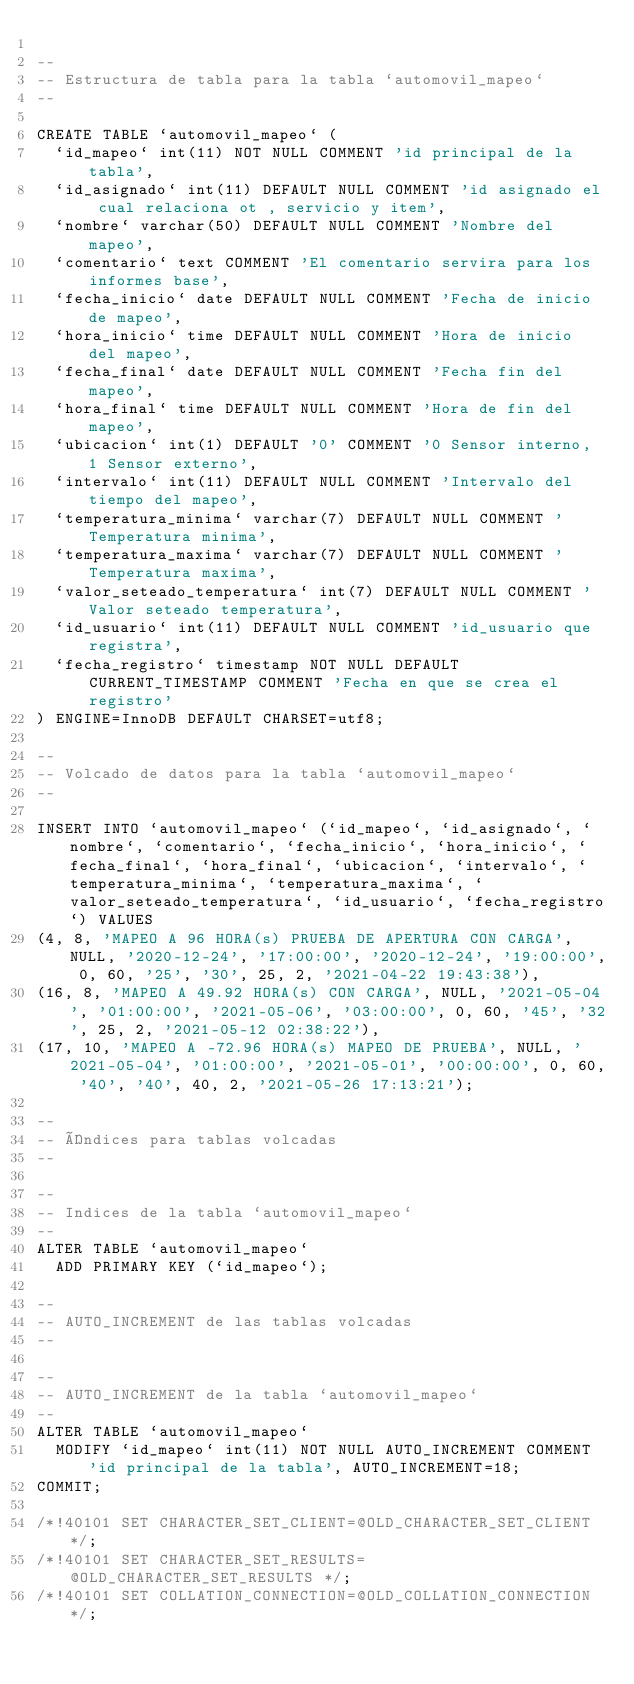<code> <loc_0><loc_0><loc_500><loc_500><_SQL_>
--
-- Estructura de tabla para la tabla `automovil_mapeo`
--

CREATE TABLE `automovil_mapeo` (
  `id_mapeo` int(11) NOT NULL COMMENT 'id principal de la tabla',
  `id_asignado` int(11) DEFAULT NULL COMMENT 'id asignado el cual relaciona ot , servicio y item',
  `nombre` varchar(50) DEFAULT NULL COMMENT 'Nombre del mapeo',
  `comentario` text COMMENT 'El comentario servira para los informes base',
  `fecha_inicio` date DEFAULT NULL COMMENT 'Fecha de inicio de mapeo',
  `hora_inicio` time DEFAULT NULL COMMENT 'Hora de inicio del mapeo',
  `fecha_final` date DEFAULT NULL COMMENT 'Fecha fin del mapeo',
  `hora_final` time DEFAULT NULL COMMENT 'Hora de fin del mapeo',
  `ubicacion` int(1) DEFAULT '0' COMMENT '0 Sensor interno, 1 Sensor externo',
  `intervalo` int(11) DEFAULT NULL COMMENT 'Intervalo del tiempo del mapeo',
  `temperatura_minima` varchar(7) DEFAULT NULL COMMENT 'Temperatura minima',
  `temperatura_maxima` varchar(7) DEFAULT NULL COMMENT 'Temperatura maxima',
  `valor_seteado_temperatura` int(7) DEFAULT NULL COMMENT 'Valor seteado temperatura',
  `id_usuario` int(11) DEFAULT NULL COMMENT 'id_usuario que registra',
  `fecha_registro` timestamp NOT NULL DEFAULT CURRENT_TIMESTAMP COMMENT 'Fecha en que se crea el registro'
) ENGINE=InnoDB DEFAULT CHARSET=utf8;

--
-- Volcado de datos para la tabla `automovil_mapeo`
--

INSERT INTO `automovil_mapeo` (`id_mapeo`, `id_asignado`, `nombre`, `comentario`, `fecha_inicio`, `hora_inicio`, `fecha_final`, `hora_final`, `ubicacion`, `intervalo`, `temperatura_minima`, `temperatura_maxima`, `valor_seteado_temperatura`, `id_usuario`, `fecha_registro`) VALUES
(4, 8, 'MAPEO A 96 HORA(s) PRUEBA DE APERTURA CON CARGA', NULL, '2020-12-24', '17:00:00', '2020-12-24', '19:00:00', 0, 60, '25', '30', 25, 2, '2021-04-22 19:43:38'),
(16, 8, 'MAPEO A 49.92 HORA(s) CON CARGA', NULL, '2021-05-04', '01:00:00', '2021-05-06', '03:00:00', 0, 60, '45', '32', 25, 2, '2021-05-12 02:38:22'),
(17, 10, 'MAPEO A -72.96 HORA(s) MAPEO DE PRUEBA', NULL, '2021-05-04', '01:00:00', '2021-05-01', '00:00:00', 0, 60, '40', '40', 40, 2, '2021-05-26 17:13:21');

--
-- Índices para tablas volcadas
--

--
-- Indices de la tabla `automovil_mapeo`
--
ALTER TABLE `automovil_mapeo`
  ADD PRIMARY KEY (`id_mapeo`);

--
-- AUTO_INCREMENT de las tablas volcadas
--

--
-- AUTO_INCREMENT de la tabla `automovil_mapeo`
--
ALTER TABLE `automovil_mapeo`
  MODIFY `id_mapeo` int(11) NOT NULL AUTO_INCREMENT COMMENT 'id principal de la tabla', AUTO_INCREMENT=18;
COMMIT;

/*!40101 SET CHARACTER_SET_CLIENT=@OLD_CHARACTER_SET_CLIENT */;
/*!40101 SET CHARACTER_SET_RESULTS=@OLD_CHARACTER_SET_RESULTS */;
/*!40101 SET COLLATION_CONNECTION=@OLD_COLLATION_CONNECTION */;
</code> 